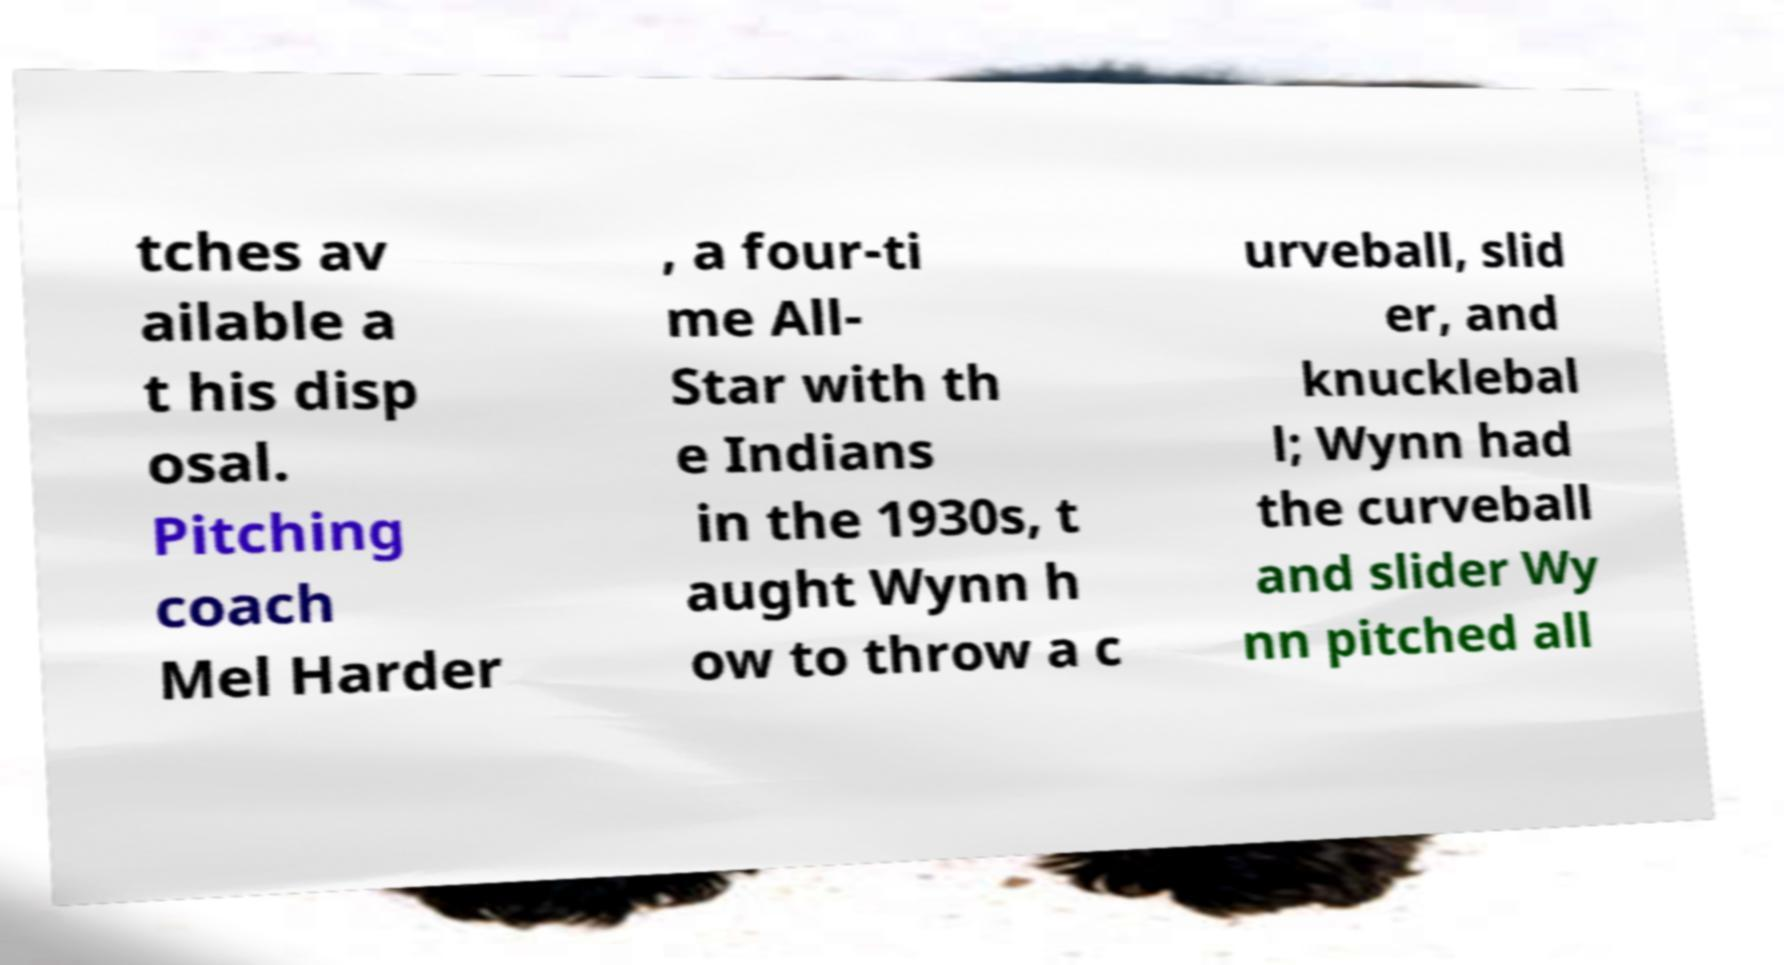Please read and relay the text visible in this image. What does it say? tches av ailable a t his disp osal. Pitching coach Mel Harder , a four-ti me All- Star with th e Indians in the 1930s, t aught Wynn h ow to throw a c urveball, slid er, and knucklebal l; Wynn had the curveball and slider Wy nn pitched all 